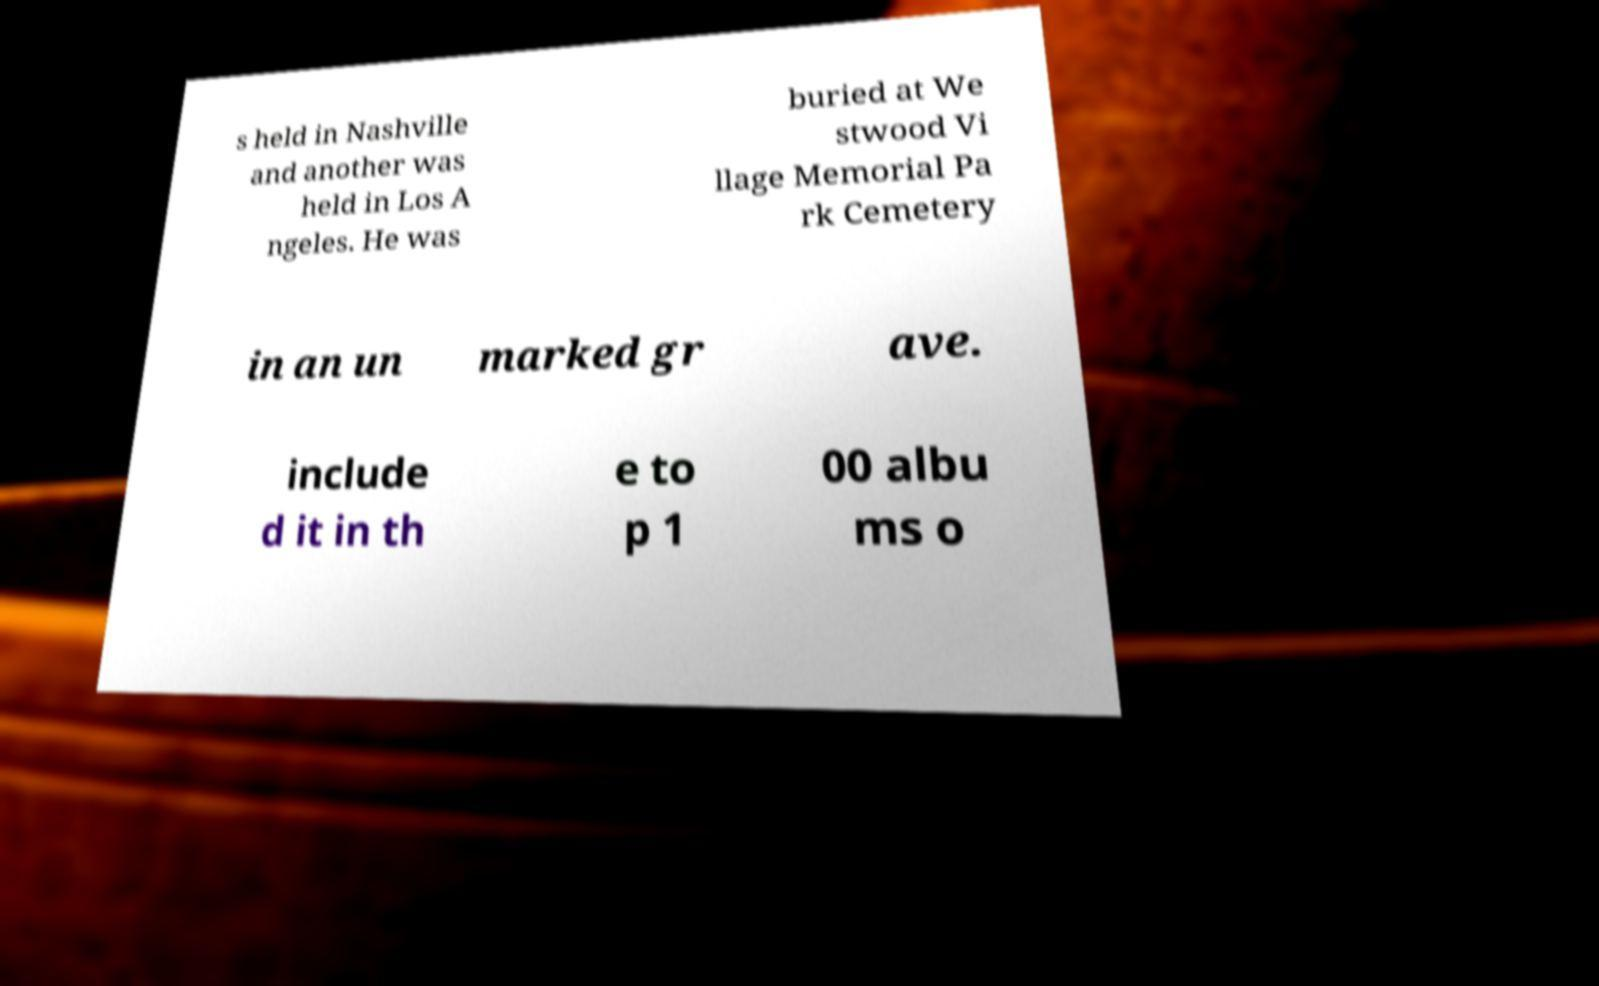Please read and relay the text visible in this image. What does it say? s held in Nashville and another was held in Los A ngeles. He was buried at We stwood Vi llage Memorial Pa rk Cemetery in an un marked gr ave. include d it in th e to p 1 00 albu ms o 